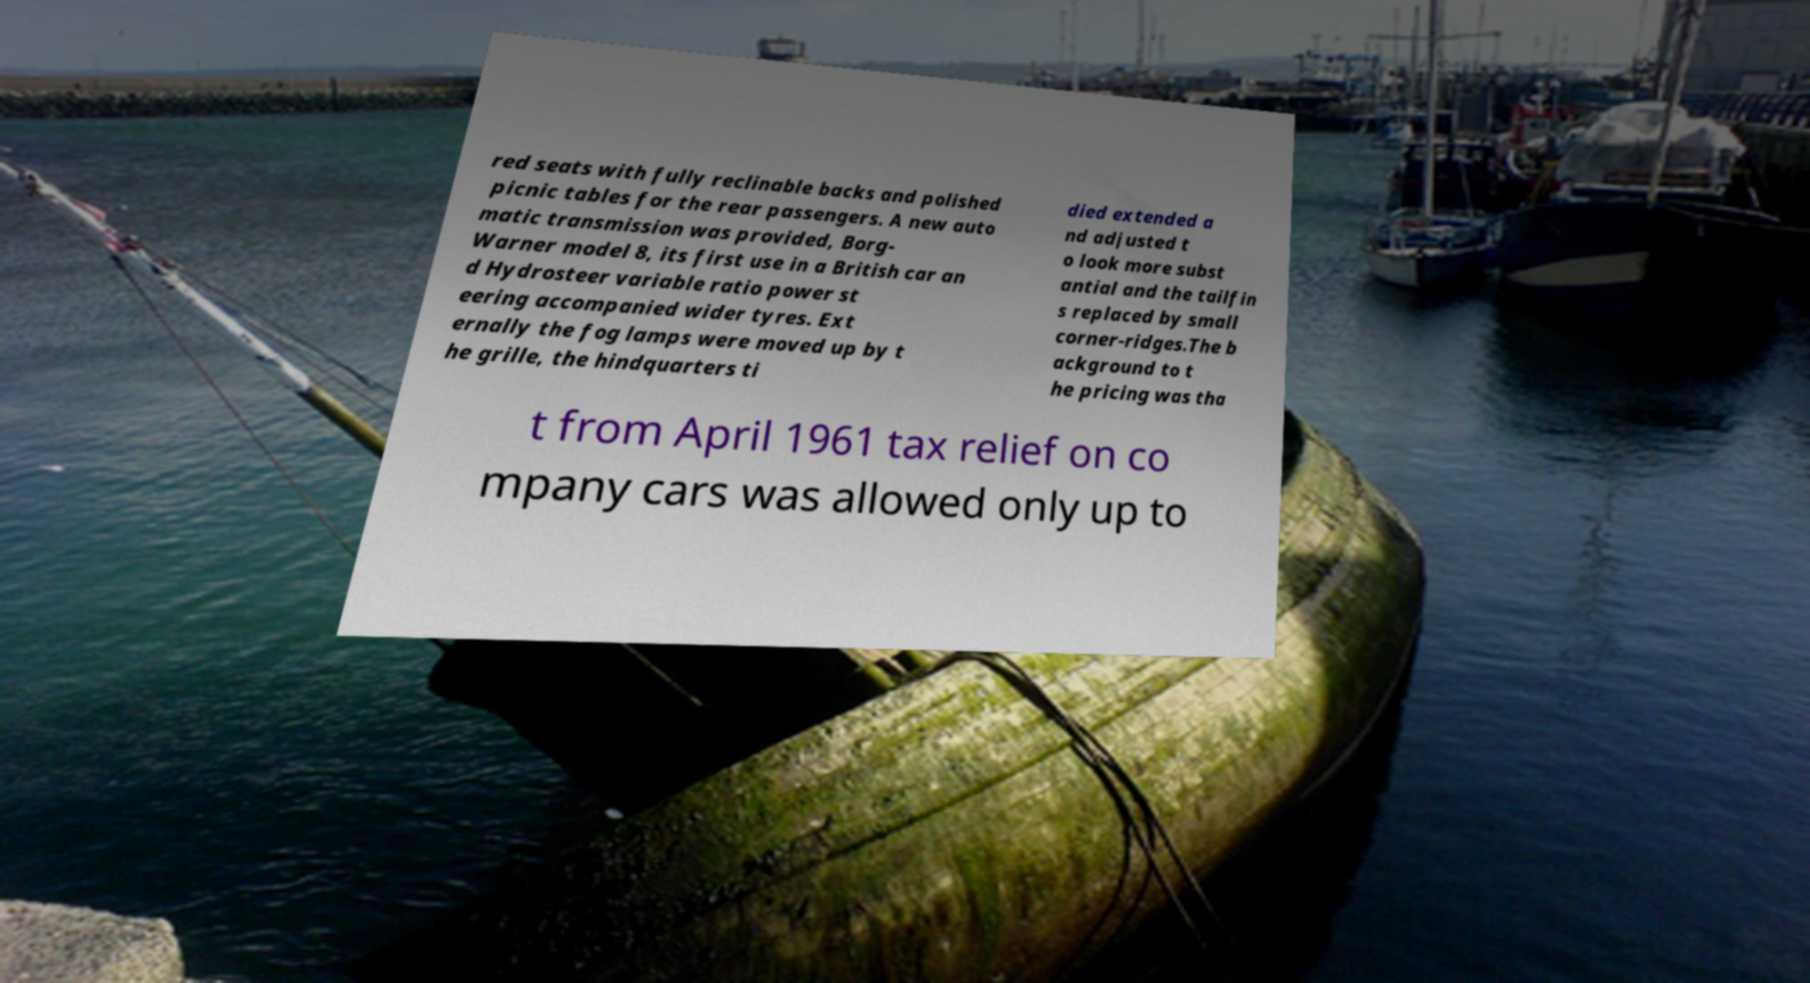I need the written content from this picture converted into text. Can you do that? red seats with fully reclinable backs and polished picnic tables for the rear passengers. A new auto matic transmission was provided, Borg- Warner model 8, its first use in a British car an d Hydrosteer variable ratio power st eering accompanied wider tyres. Ext ernally the fog lamps were moved up by t he grille, the hindquarters ti died extended a nd adjusted t o look more subst antial and the tailfin s replaced by small corner-ridges.The b ackground to t he pricing was tha t from April 1961 tax relief on co mpany cars was allowed only up to 